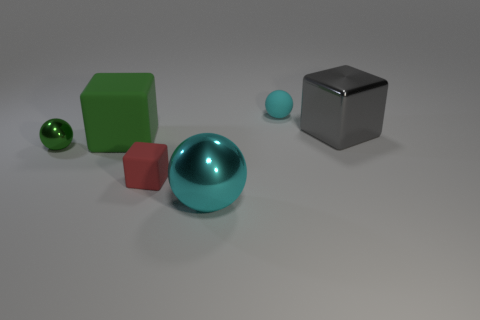Subtract all big green matte cubes. How many cubes are left? 2 Subtract 1 cubes. How many cubes are left? 2 Subtract all brown cylinders. How many cyan spheres are left? 2 Add 3 tiny rubber balls. How many objects exist? 9 Subtract all cyan balls. How many balls are left? 1 Subtract 0 green cylinders. How many objects are left? 6 Subtract all cyan balls. Subtract all brown cylinders. How many balls are left? 1 Subtract all cubes. Subtract all green metallic cubes. How many objects are left? 3 Add 5 tiny objects. How many tiny objects are left? 8 Add 2 big purple objects. How many big purple objects exist? 2 